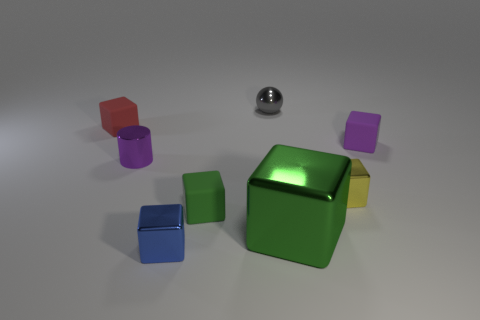Do the purple metallic thing and the tiny yellow thing have the same shape? no 